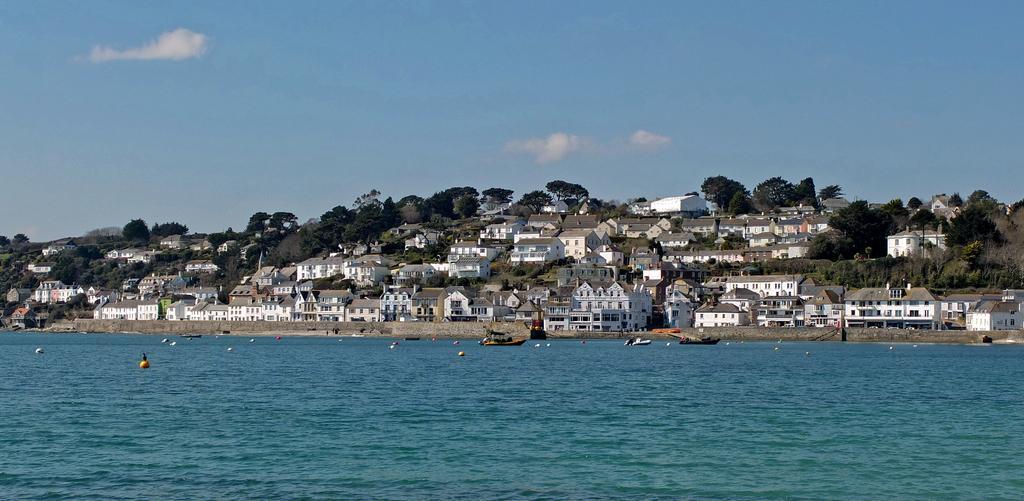In one or two sentences, can you explain what this image depicts? At the bottom of the image there is water with birds on it. Behind the water there are houses with roofs, walls and windows. Also there are trees and poles. At the top of the image there is a sky. 